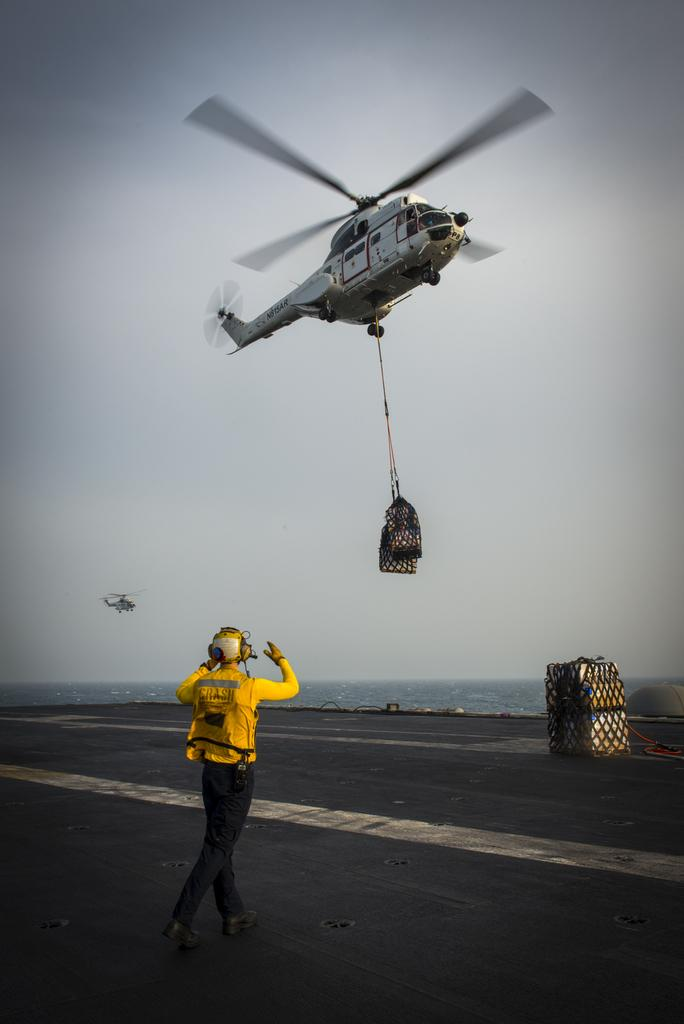Who or what is present in the image? There is a person in the image. What can be seen on the ground in the image? There is an object on the ground in the image. What is happening in the background of the image? Helicopters are flying in the background of the image. What part of the natural environment is visible in the image? The sky is visible in the background of the image. What type of ray is swimming in the air in the image? There is no ray present in the image; it is a person, an object on the ground, helicopters, and the sky that are visible. 